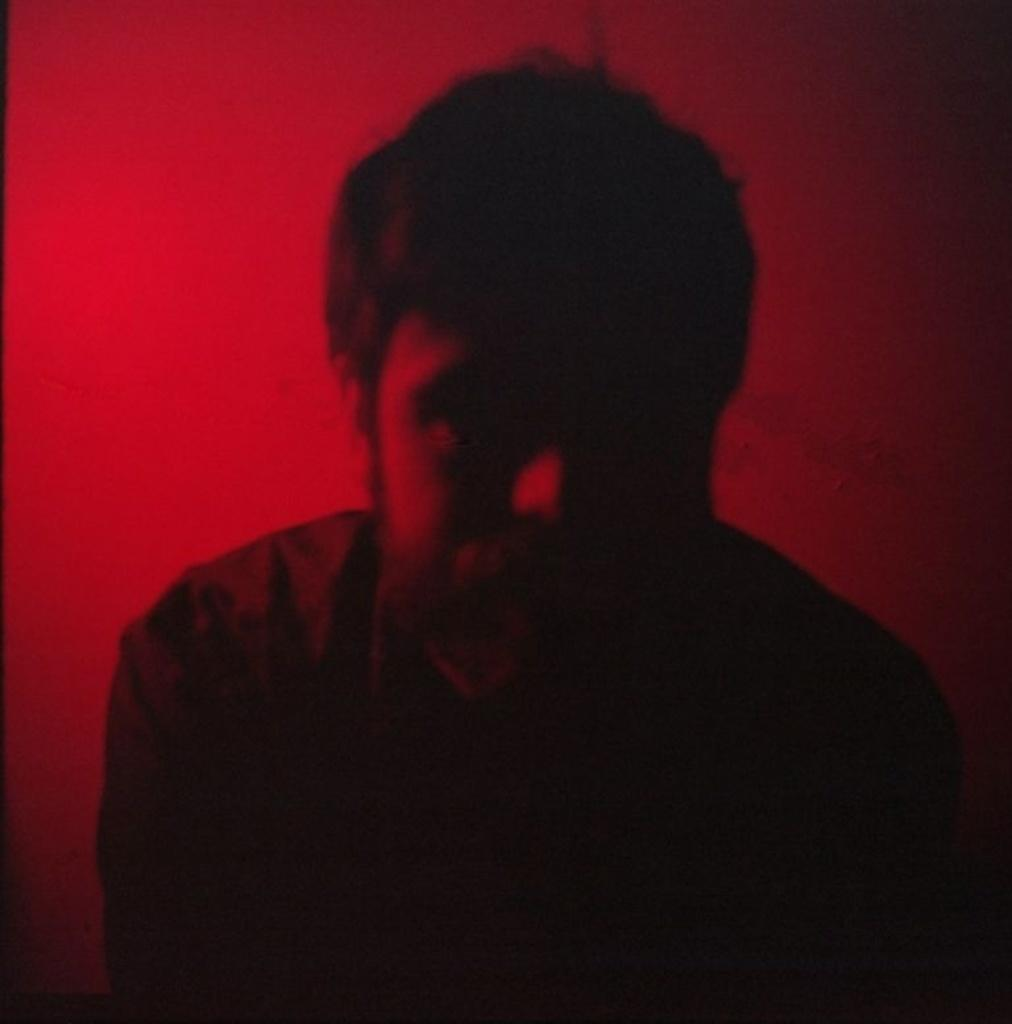What is the main subject of the image? There is a person in the image. What color is the background of the image? The background color is red. Can you describe the lighting conditions in the image? The image was taken in a dark environment. What type of sofa is visible in the image? There is no sofa present in the image. Who is sitting on the throne in the image? There is no throne present in the image. 